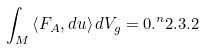<formula> <loc_0><loc_0><loc_500><loc_500>\int _ { M } \left < F _ { A } , d u \right > d V _ { g } = 0 . ^ { n } { 2 . 3 . 2 }</formula> 